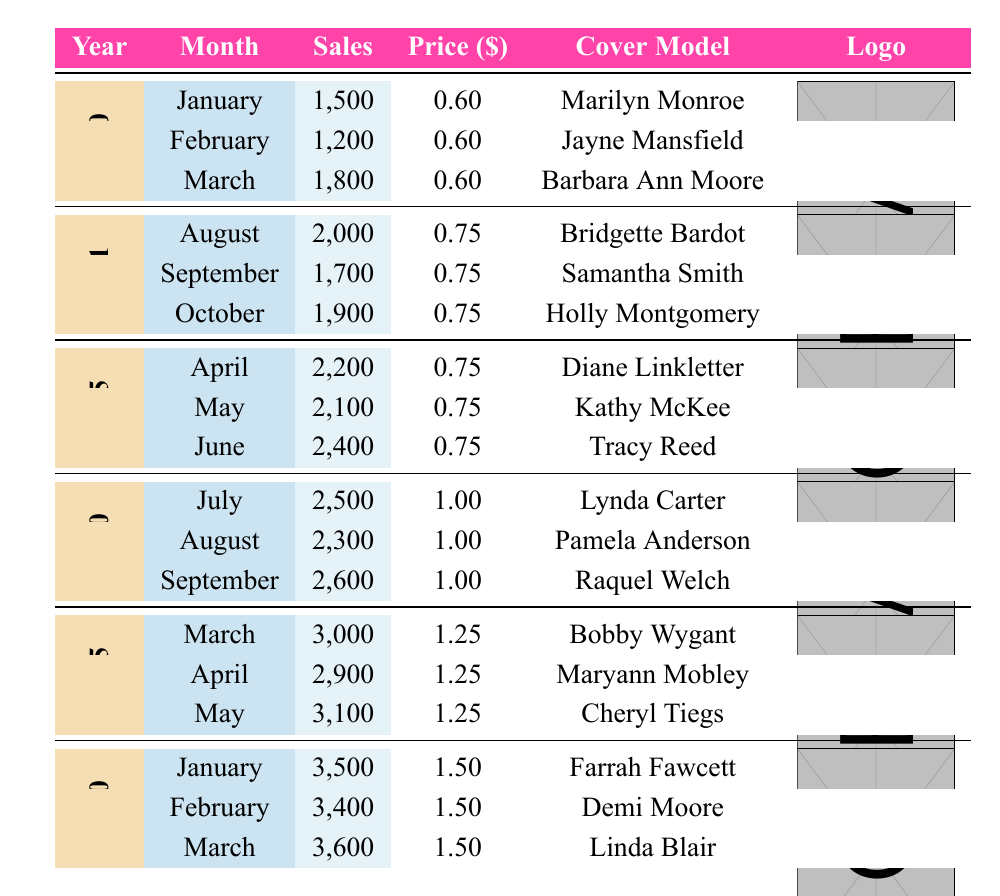What was the best-selling month in 1965? To find the best-selling month in 1965, I look for the maximum sales value in the row corresponding to 1965. The sales values for April, May, and June are 2200, 2100, and 2400 respectively. June has the highest sales at 2400.
Answer: June How many total sales occurred in 1970? To calculate the total sales in 1970, I add the sales from each month: July (2500) + August (2300) + September (2600) = 2500 + 2300 + 2600 = 7400.
Answer: 7400 Was Marilyn Monroe the cover model for any issue in 1960? Referring to the table, in 1960, the cover model for January is Marilyn Monroe. Thus, it is true that she was featured.
Answer: Yes What was the average sales price from 1960 to 1980? First, I take the price values from each year: 1960 (0.60), 1961 (0.75), 1965 (0.75), 1970 (1.00), 1975 (1.25), and 1980 (1.50). Then, I sum these prices: 0.60 + 0.75 + 0.75 + 1.00 + 1.25 + 1.50 = 5.85. There are six data points, so I divide by 6 to get the average: 5.85 / 6 = 0.975.
Answer: 0.975 Which cover model had the highest sales month in 1975? In 1975, we have March (3000), April (2900), and May (3100). The sales in May were the highest at 3100, and the cover model for that month was Cheryl Tiegs.
Answer: Cheryl Tiegs 